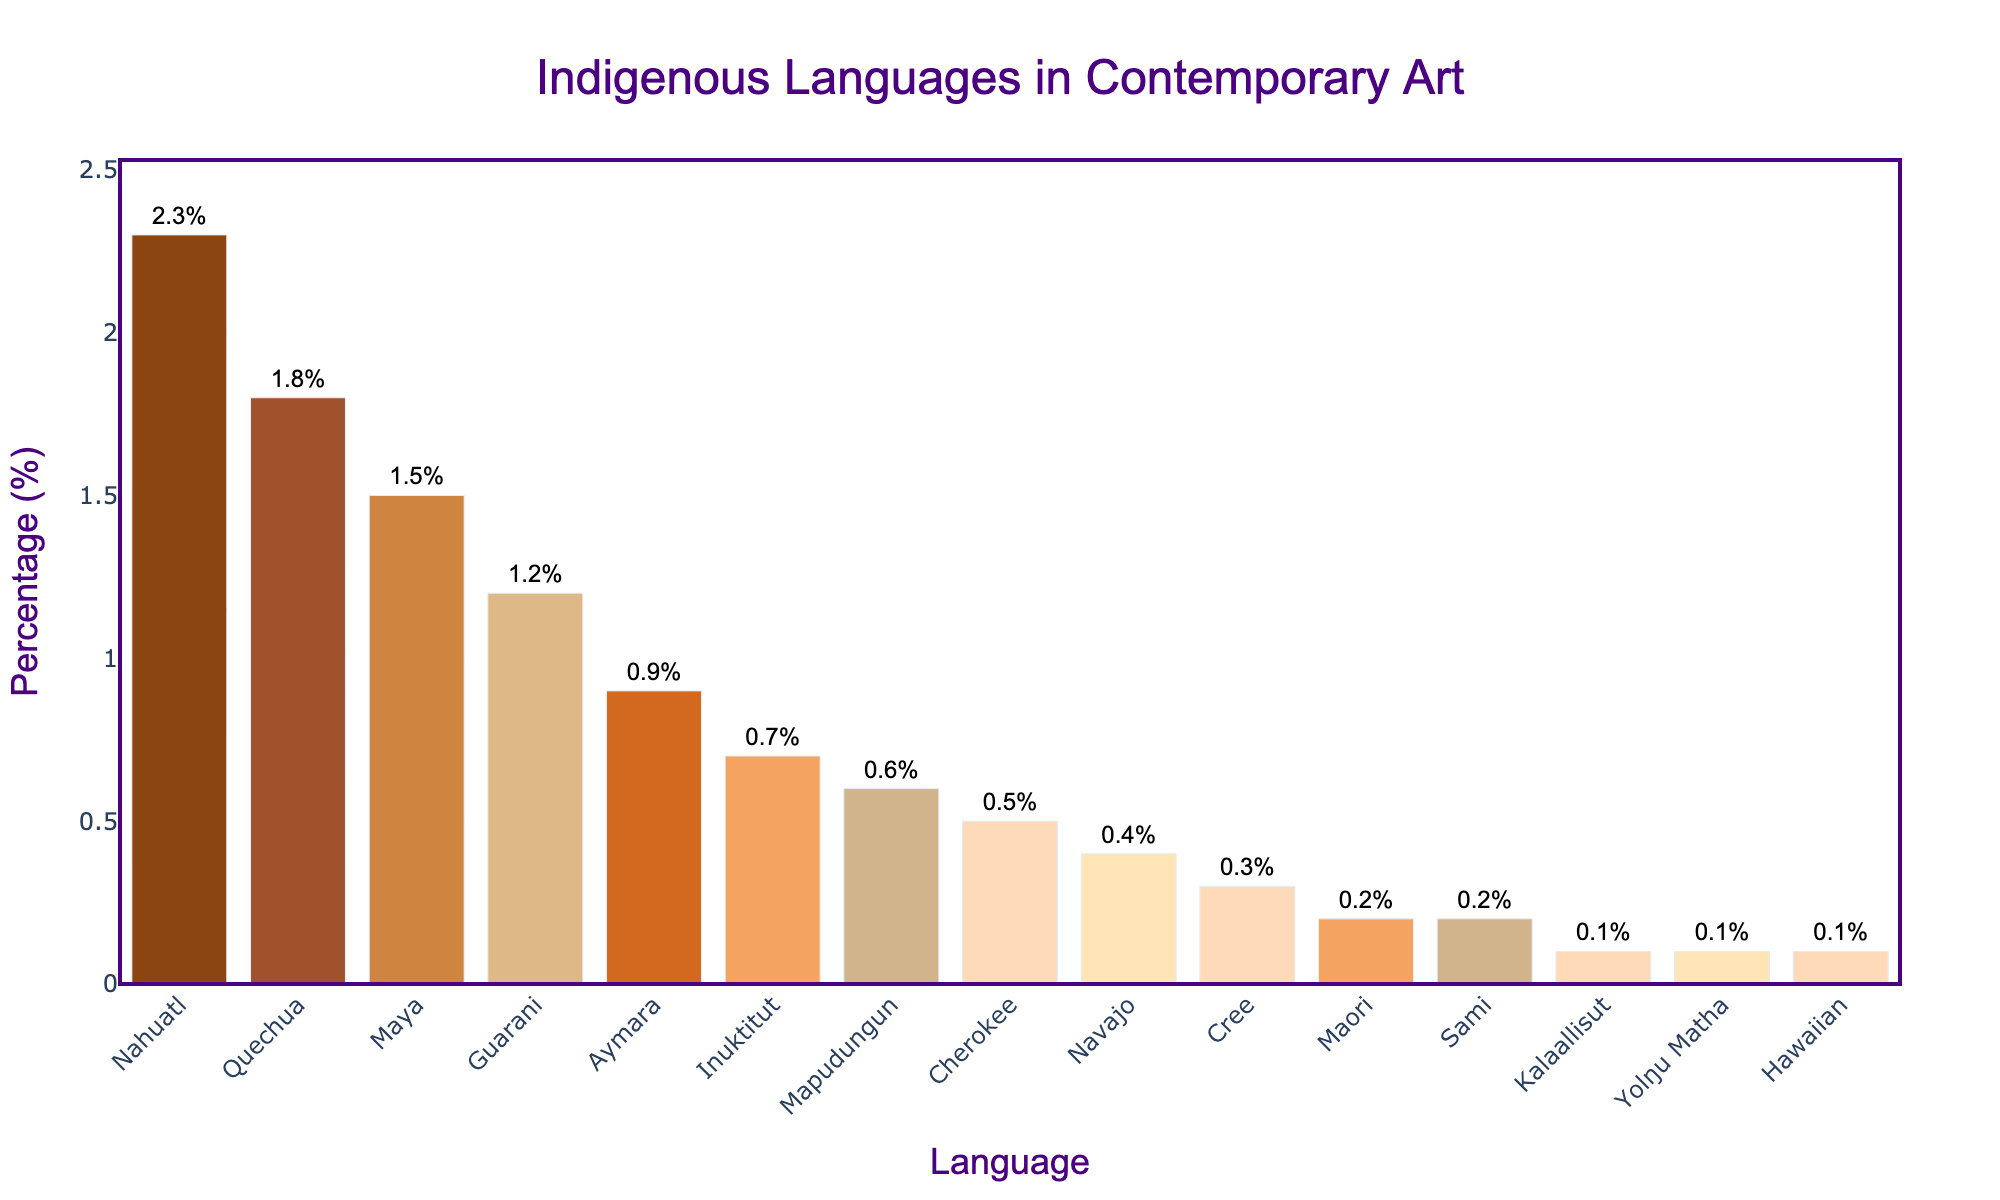Which indigenous language has the highest percentage of usage in contemporary art titles and descriptions? By observing the height of the bars, Nahuatl has the tallest bar, indicating it has the highest percentage of usage.
Answer: Nahuatl Which language has a higher percentage of usage, Quechua or Maya? By comparing the heights of the bars for Quechua and Maya, Quechua is higher, indicating a higher percentage.
Answer: Quechua What is the total percentage of the top three languages? Add the percentages of Nahuatl (2.3%), Quechua (1.8%), and Maya (1.5%): 2.3 + 1.8 + 1.5 = 5.6%.
Answer: 5.6% How does the usage of Aymara compare to Guarani? By comparing the bar heights, Aymara's height is less than Guarani's, indicating a lower percentage.
Answer: Guarani has a higher percentage What is the combined percentage of Cherokee and Navajo? Add the percentages of Cherokee (0.5%) and Navajo (0.4%): 0.5 + 0.4 = 0.9%.
Answer: 0.9% Which language has the smallest percentage of usage? By looking at the bar lengths, Kalaallisut, Yolŋu Matha, and Hawaiian have the shortest bars, each indicating 0.1%.
Answer: Kalaallisut, Yolŋu Matha, Hawaiian Is the percentage of Inuktitut closer to Aymara or Cherokee? Inuktitut (0.7%) is closer to Aymara (0.9%) than to Cherokee (0.5%) when comparing the values.
Answer: Aymara Compare the number of languages with a usage percentage of 0.1% to those with a usage percentage of 0.2%. There are three languages with 0.1% and two languages with 0.2%.
Answer: More languages have 0.1% usage than 0.2% What is the average percentage usage of Guarani, Aymara, and Inuktitut? Add the percentages of Guarani (1.2%), Aymara (0.9%), and Inuktitut (0.7%), and then divide by 3: (1.2 + 0.9 + 0.7) / 3 = 2.8 / 3 ≈ 0.93%.
Answer: Approximately 0.93% Which language's bar color is lightest? By observing the color hues, the bar for Hawaiian appears lightest with a peach shade.
Answer: Hawaiian 